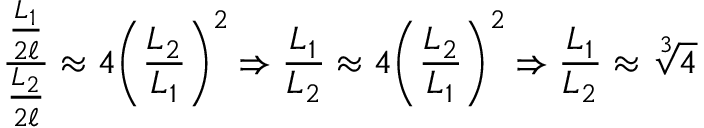<formula> <loc_0><loc_0><loc_500><loc_500>{ \frac { \frac { L _ { 1 } } { 2 \ell } } { \frac { L _ { 2 } } { 2 \ell } } } \approx 4 { \left ( { \frac { L _ { 2 } } { L _ { 1 } } } \right ) } ^ { 2 } \Rightarrow { \frac { L _ { 1 } } { L _ { 2 } } } \approx 4 { \left ( { \frac { L _ { 2 } } { L _ { 1 } } } \right ) } ^ { 2 } \Rightarrow { \frac { L _ { 1 } } { L _ { 2 } } } \approx { \sqrt { [ } { 3 } ] { 4 } }</formula> 